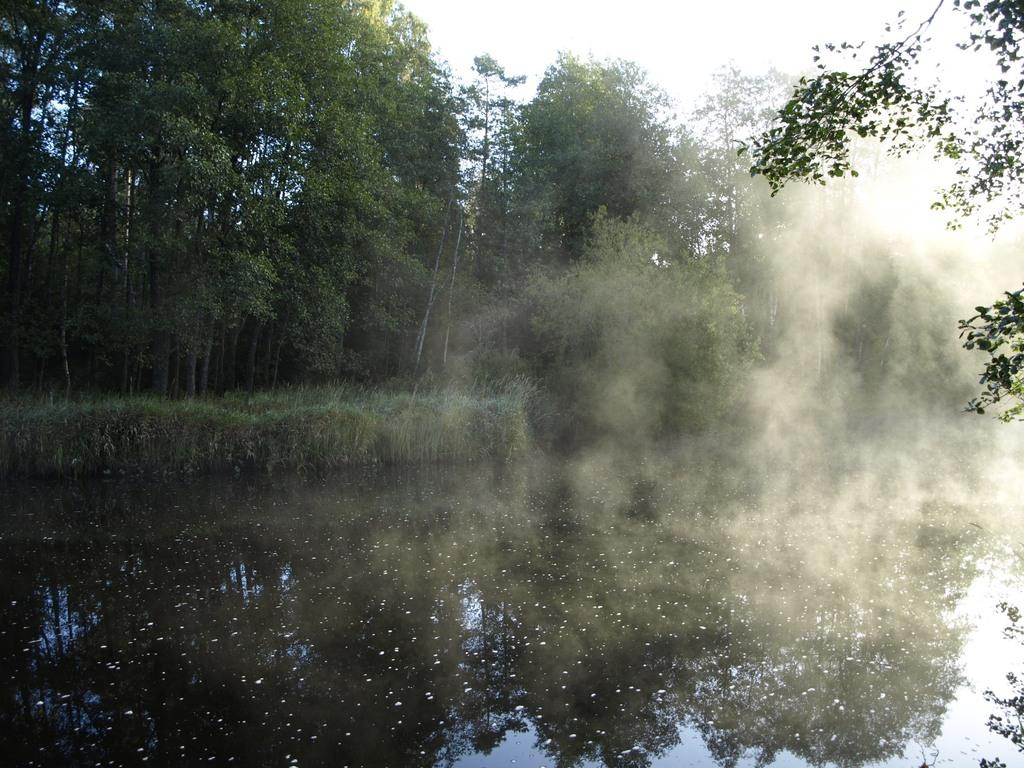What is the main feature of the image? The main feature of the image is a water surface. What can be seen behind the water surface? There is a lot of grass behind the water surface, followed by very tall trees. Is there any visible smoke in the image? Yes, there is some smoke visible in the area. What type of needle is being used by the fowl in the image? There is no fowl or needle present in the image. 